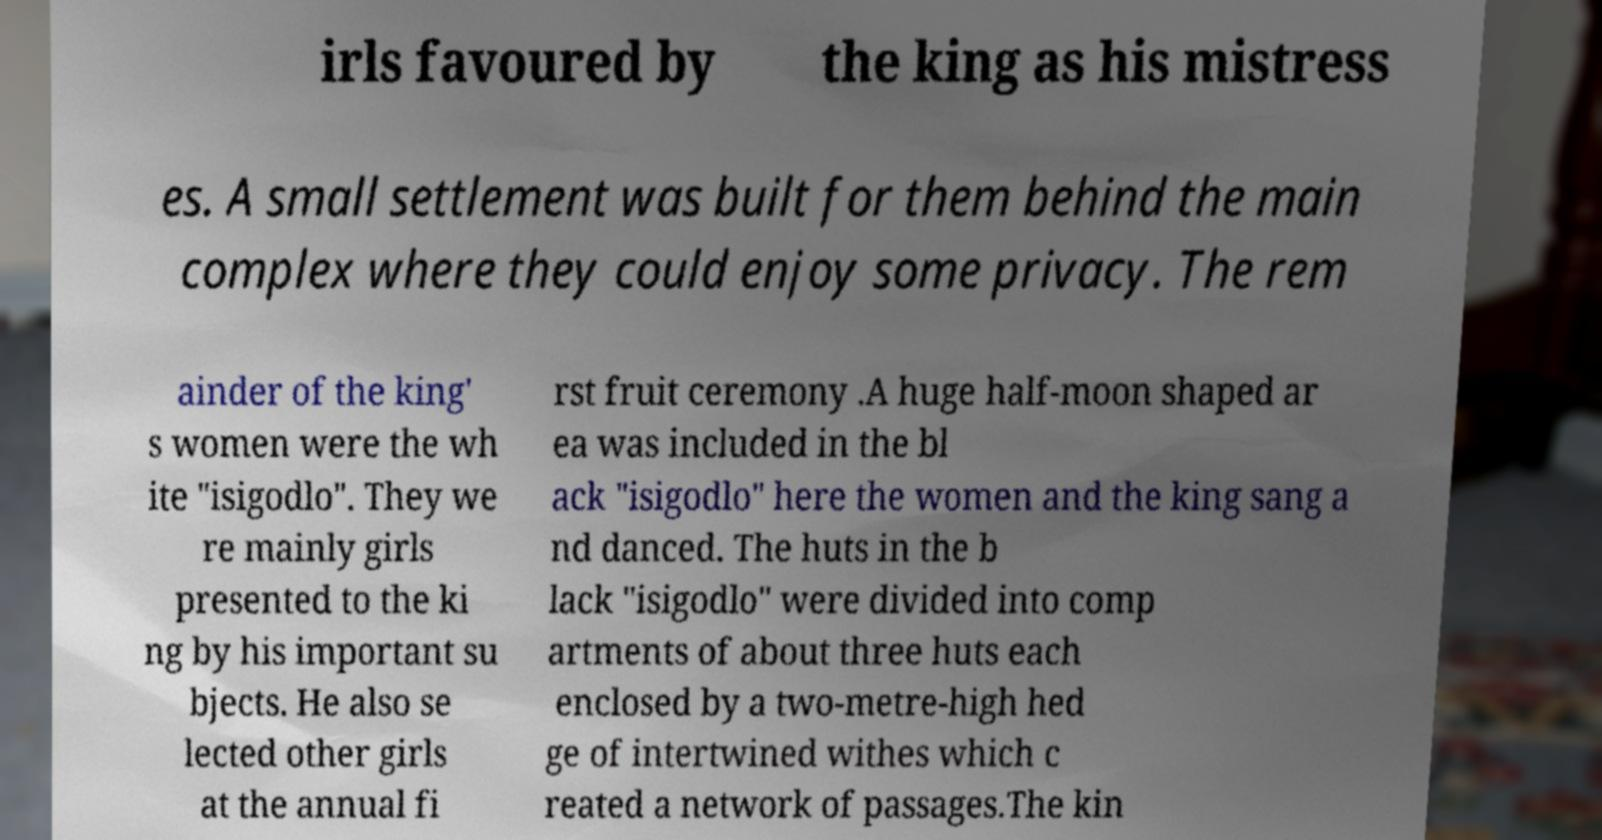Can you accurately transcribe the text from the provided image for me? irls favoured by the king as his mistress es. A small settlement was built for them behind the main complex where they could enjoy some privacy. The rem ainder of the king' s women were the wh ite "isigodlo". They we re mainly girls presented to the ki ng by his important su bjects. He also se lected other girls at the annual fi rst fruit ceremony .A huge half-moon shaped ar ea was included in the bl ack "isigodlo" here the women and the king sang a nd danced. The huts in the b lack "isigodlo" were divided into comp artments of about three huts each enclosed by a two-metre-high hed ge of intertwined withes which c reated a network of passages.The kin 